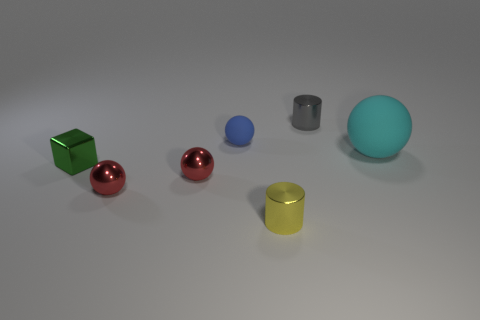What material is the tiny gray thing that is the same shape as the tiny yellow thing?
Give a very brief answer. Metal. What material is the cyan sphere?
Make the answer very short. Rubber. Do the gray shiny cylinder that is behind the yellow metallic cylinder and the yellow metal object have the same size?
Give a very brief answer. Yes. What is the size of the metallic cylinder behind the small block?
Make the answer very short. Small. Is there anything else that has the same material as the yellow cylinder?
Your response must be concise. Yes. What number of red balls are there?
Provide a short and direct response. 2. Does the big object have the same color as the small metallic cube?
Your answer should be compact. No. What is the color of the object that is to the right of the yellow thing and in front of the gray object?
Your response must be concise. Cyan. Are there any small gray cylinders left of the tiny gray metallic object?
Offer a very short reply. No. What number of gray shiny objects are in front of the tiny shiny cylinder in front of the small shiny cube?
Ensure brevity in your answer.  0. 